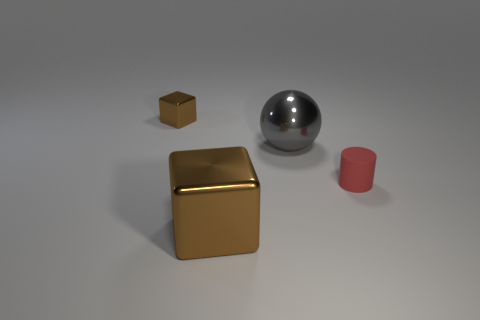Add 3 brown cubes. How many objects exist? 7 Subtract all balls. How many objects are left? 3 Subtract 1 cubes. How many cubes are left? 1 Subtract all yellow balls. How many yellow cylinders are left? 0 Subtract all cyan matte cubes. Subtract all metal spheres. How many objects are left? 3 Add 1 big blocks. How many big blocks are left? 2 Add 1 big gray cubes. How many big gray cubes exist? 1 Subtract 1 brown blocks. How many objects are left? 3 Subtract all yellow cubes. Subtract all red cylinders. How many cubes are left? 2 